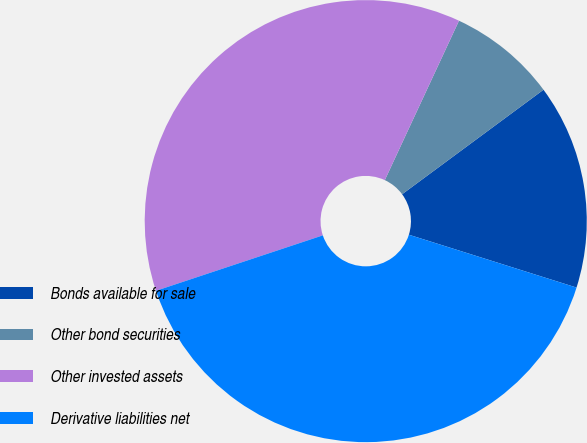Convert chart. <chart><loc_0><loc_0><loc_500><loc_500><pie_chart><fcel>Bonds available for sale<fcel>Other bond securities<fcel>Other invested assets<fcel>Derivative liabilities net<nl><fcel>14.99%<fcel>7.94%<fcel>37.04%<fcel>40.04%<nl></chart> 